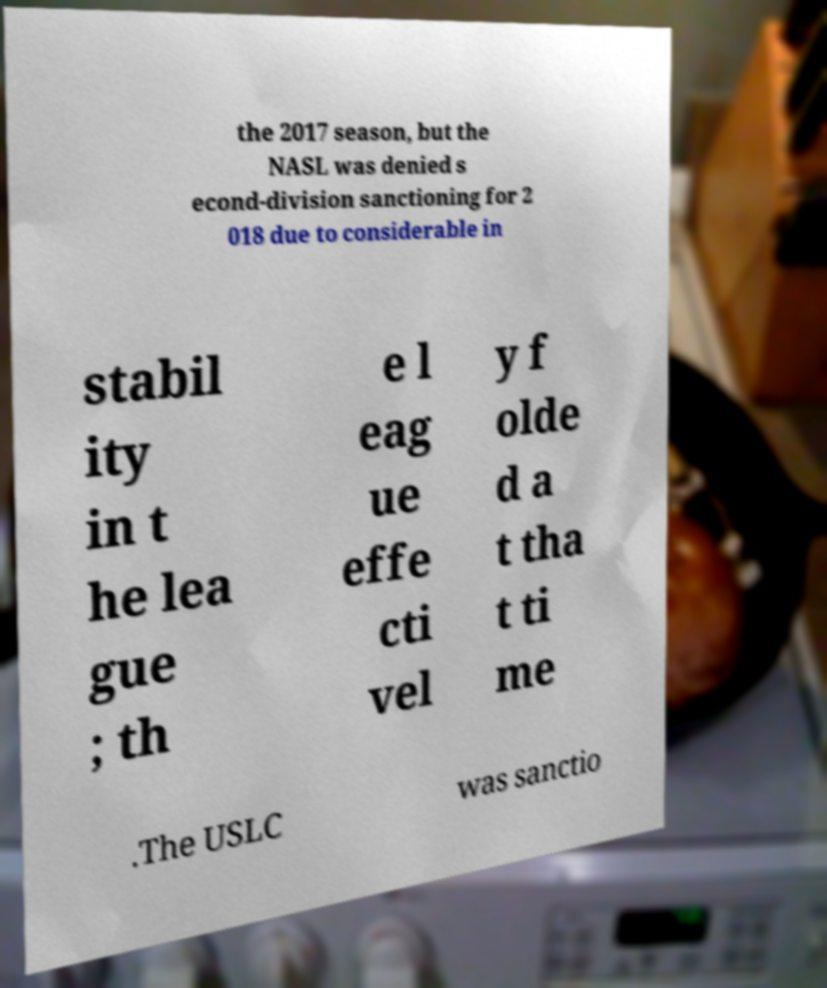Please read and relay the text visible in this image. What does it say? the 2017 season, but the NASL was denied s econd-division sanctioning for 2 018 due to considerable in stabil ity in t he lea gue ; th e l eag ue effe cti vel y f olde d a t tha t ti me .The USLC was sanctio 